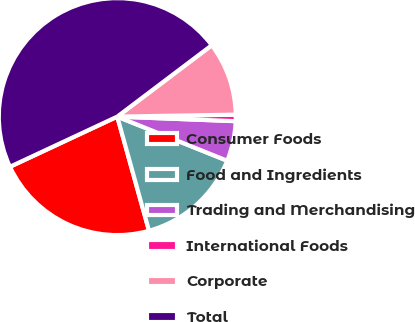Convert chart to OTSL. <chart><loc_0><loc_0><loc_500><loc_500><pie_chart><fcel>Consumer Foods<fcel>Food and Ingredients<fcel>Trading and Merchandising<fcel>International Foods<fcel>Corporate<fcel>Total<nl><fcel>22.36%<fcel>14.61%<fcel>5.46%<fcel>0.88%<fcel>10.03%<fcel>46.66%<nl></chart> 